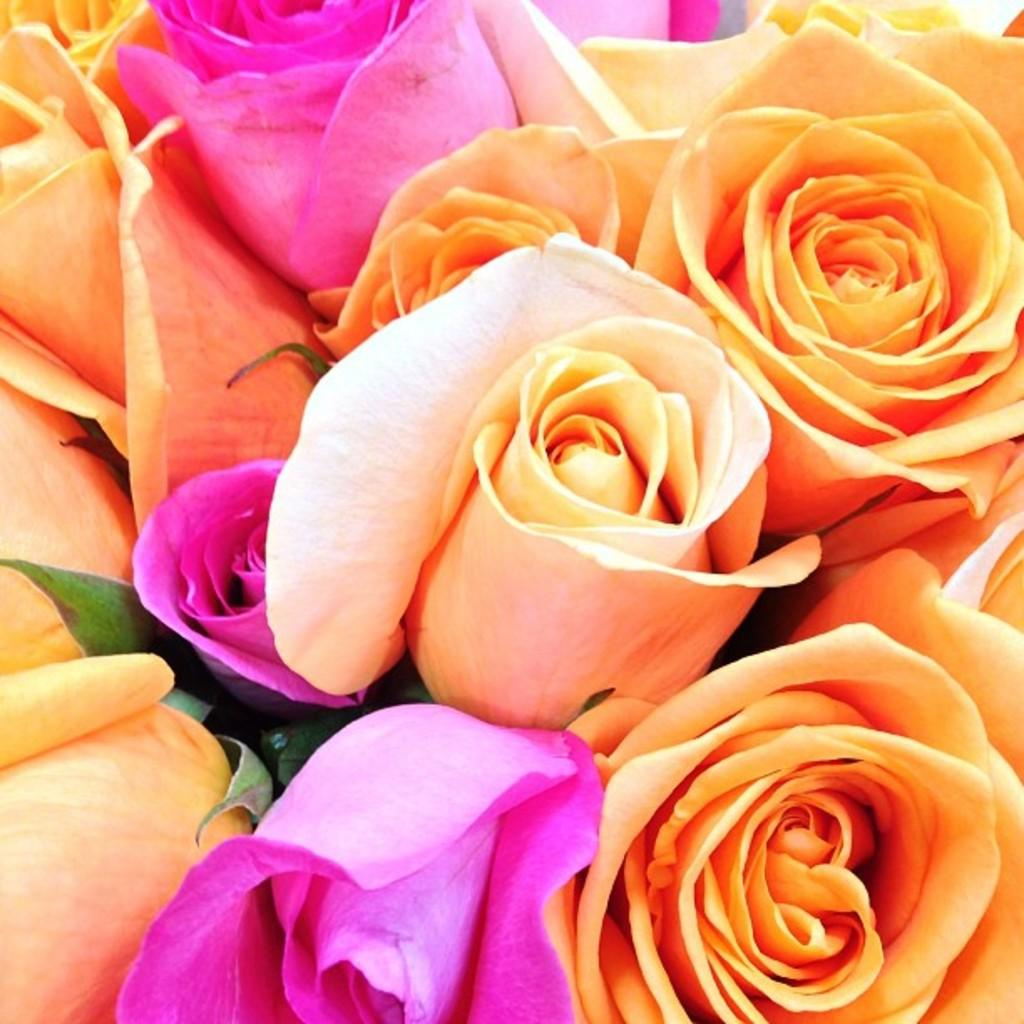What type of flowers are present in the image? There are orange roses and pink roses in the image. Can you describe the colors of the roses? The orange roses are orange, and the pink roses are pink. What is the reason for the sidewalk being present in the image? There is no sidewalk present in the image; it only features orange and pink roses. 